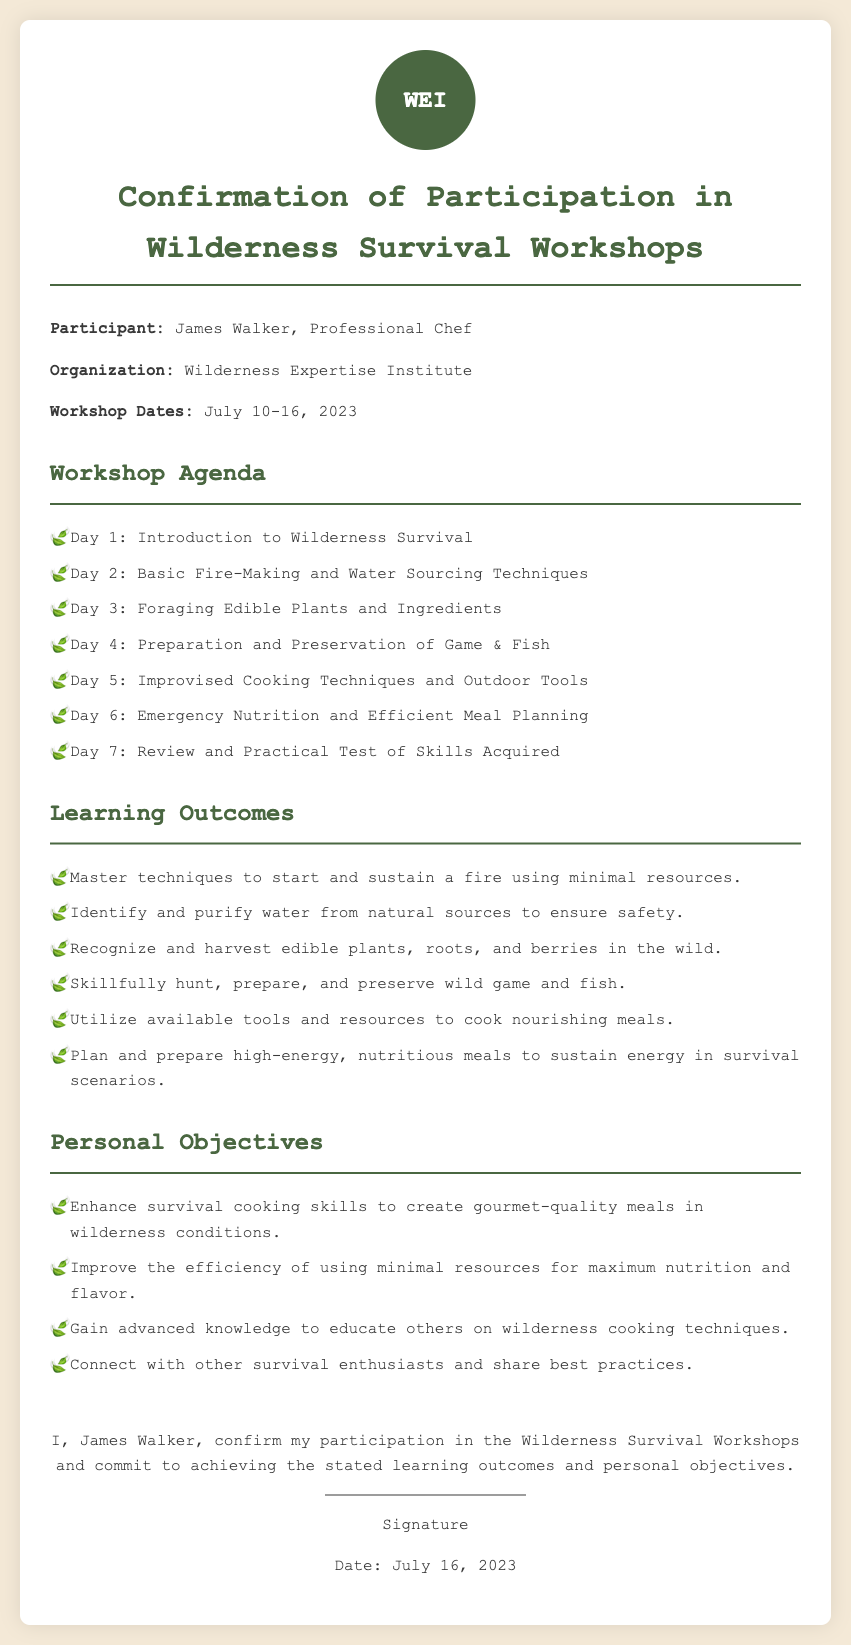What is the name of the participant? The document states that the participant's name is James Walker.
Answer: James Walker What organization is conducting the workshop? The organization mentioned in the document is the Wilderness Expertise Institute.
Answer: Wilderness Expertise Institute What are the workshop dates? The document specifies that the workshop dates are July 10-16, 2023.
Answer: July 10-16, 2023 Which day focuses on foraging edible plants? The agenda indicates that Day 3 is dedicated to foraging edible plants and ingredients.
Answer: Day 3 What is one learning outcome related to fire? The document states that a learning outcome includes mastering techniques to start and sustain a fire using minimal resources.
Answer: Start and sustain a fire What personal objective involves sharing knowledge? One of the personal objectives is to gain advanced knowledge to educate others on wilderness cooking techniques.
Answer: Educate others How many days is the workshop scheduled for? The agenda outlines a total of 7 workshop days conducted from July 10 to July 16.
Answer: 7 days What is the last day of the workshop's practical test? The final day, Day 7, is reserved for a review and practical test of skills acquired.
Answer: Day 7 What type of signature is required in the document? The document requires a handwritten signature from the participant, James Walker.
Answer: Signature 